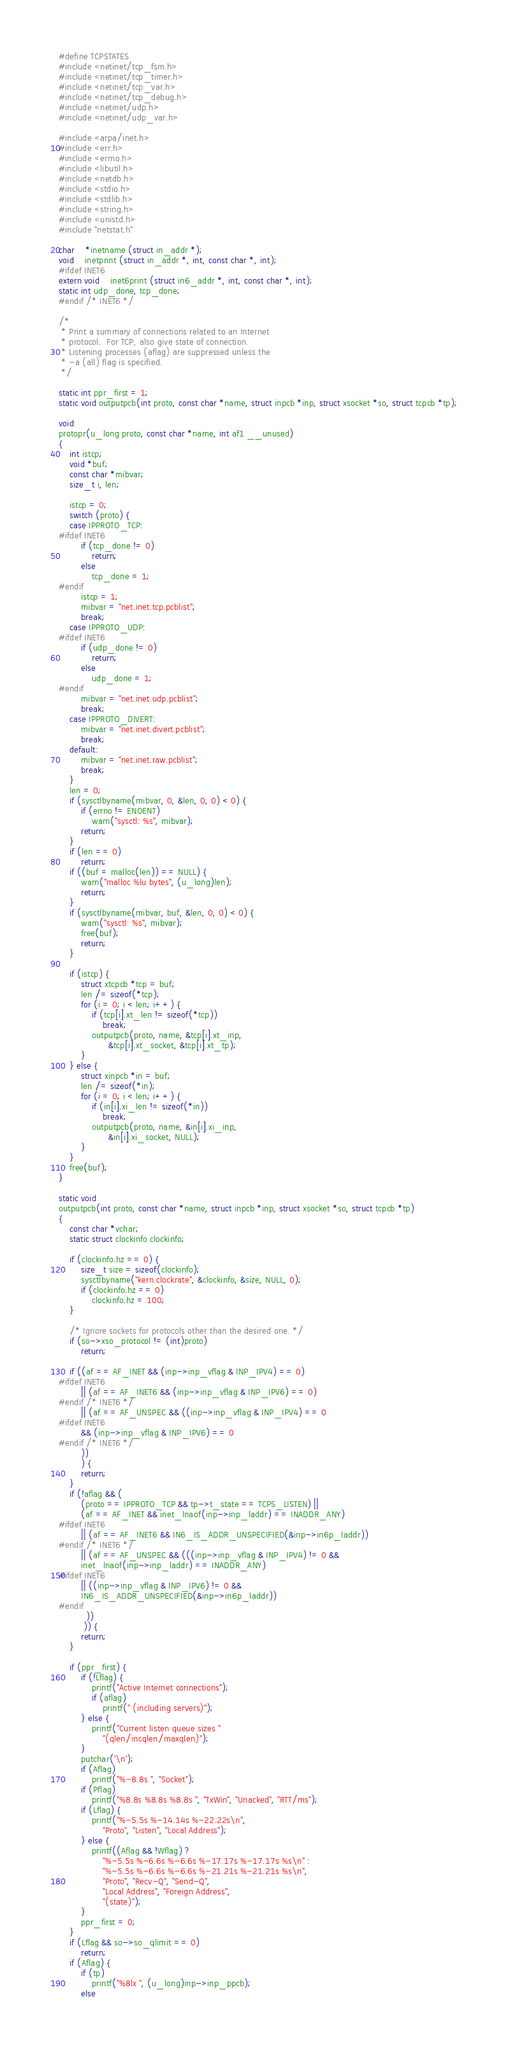Convert code to text. <code><loc_0><loc_0><loc_500><loc_500><_C_>#define TCPSTATES
#include <netinet/tcp_fsm.h>
#include <netinet/tcp_timer.h>
#include <netinet/tcp_var.h>
#include <netinet/tcp_debug.h>
#include <netinet/udp.h>
#include <netinet/udp_var.h>

#include <arpa/inet.h>
#include <err.h>
#include <errno.h>
#include <libutil.h>
#include <netdb.h>
#include <stdio.h>
#include <stdlib.h>
#include <string.h>
#include <unistd.h>
#include "netstat.h"

char	*inetname (struct in_addr *);
void	inetprint (struct in_addr *, int, const char *, int);
#ifdef INET6
extern void	inet6print (struct in6_addr *, int, const char *, int);
static int udp_done, tcp_done;
#endif /* INET6 */

/*
 * Print a summary of connections related to an Internet
 * protocol.  For TCP, also give state of connection.
 * Listening processes (aflag) are suppressed unless the
 * -a (all) flag is specified.
 */

static int ppr_first = 1;
static void outputpcb(int proto, const char *name, struct inpcb *inp, struct xsocket *so, struct tcpcb *tp);

void
protopr(u_long proto, const char *name, int af1 __unused)
{
	int istcp;
	void *buf;
	const char *mibvar;
	size_t i, len;

	istcp = 0;
	switch (proto) {
	case IPPROTO_TCP:
#ifdef INET6
		if (tcp_done != 0)
			return;
		else
			tcp_done = 1;
#endif
		istcp = 1;
		mibvar = "net.inet.tcp.pcblist";
		break;
	case IPPROTO_UDP:
#ifdef INET6
		if (udp_done != 0)
			return;
		else
			udp_done = 1;
#endif
		mibvar = "net.inet.udp.pcblist";
		break;
	case IPPROTO_DIVERT:
		mibvar = "net.inet.divert.pcblist";
		break;
	default:
		mibvar = "net.inet.raw.pcblist";
		break;
	}
	len = 0;
	if (sysctlbyname(mibvar, 0, &len, 0, 0) < 0) {
		if (errno != ENOENT)
			warn("sysctl: %s", mibvar);
		return;
	}
	if (len == 0)
		return;
	if ((buf = malloc(len)) == NULL) {
		warn("malloc %lu bytes", (u_long)len);
		return;
	}
	if (sysctlbyname(mibvar, buf, &len, 0, 0) < 0) {
		warn("sysctl: %s", mibvar);
		free(buf);
		return;
	}

	if (istcp) {
		struct xtcpcb *tcp = buf;
		len /= sizeof(*tcp);
		for (i = 0; i < len; i++) {
			if (tcp[i].xt_len != sizeof(*tcp))
				break;
			outputpcb(proto, name, &tcp[i].xt_inp,
				  &tcp[i].xt_socket, &tcp[i].xt_tp);
		}
	} else {
		struct xinpcb *in = buf;
		len /= sizeof(*in);
		for (i = 0; i < len; i++) {
			if (in[i].xi_len != sizeof(*in))
				break;
			outputpcb(proto, name, &in[i].xi_inp,
				  &in[i].xi_socket, NULL);
		}
	}
	free(buf);
}

static void
outputpcb(int proto, const char *name, struct inpcb *inp, struct xsocket *so, struct tcpcb *tp)
{
	const char *vchar;
	static struct clockinfo clockinfo;

	if (clockinfo.hz == 0) {
		size_t size = sizeof(clockinfo);
		sysctlbyname("kern.clockrate", &clockinfo, &size, NULL, 0);
		if (clockinfo.hz == 0)
			clockinfo.hz = 100;
	}

	/* Ignore sockets for protocols other than the desired one. */
	if (so->xso_protocol != (int)proto)
		return;

	if ((af == AF_INET && (inp->inp_vflag & INP_IPV4) == 0)
#ifdef INET6
	    || (af == AF_INET6 && (inp->inp_vflag & INP_IPV6) == 0)
#endif /* INET6 */
	    || (af == AF_UNSPEC && ((inp->inp_vflag & INP_IPV4) == 0
#ifdef INET6
		&& (inp->inp_vflag & INP_IPV6) == 0
#endif /* INET6 */
		))
	    ) {
		return;
	}
	if (!aflag && ( 
		(proto == IPPROTO_TCP && tp->t_state == TCPS_LISTEN) ||
		(af == AF_INET && inet_lnaof(inp->inp_laddr) == INADDR_ANY)
#ifdef INET6
	    || (af == AF_INET6 && IN6_IS_ADDR_UNSPECIFIED(&inp->in6p_laddr))
#endif /* INET6 */
	    || (af == AF_UNSPEC && (((inp->inp_vflag & INP_IPV4) != 0 &&
		inet_lnaof(inp->inp_laddr) == INADDR_ANY)
#ifdef INET6
	    || ((inp->inp_vflag & INP_IPV6) != 0 &&
		IN6_IS_ADDR_UNSPECIFIED(&inp->in6p_laddr))
#endif
		  ))
	     )) {
		return;
	}

	if (ppr_first) {
		if (!Lflag) {
			printf("Active Internet connections");
			if (aflag)
				printf(" (including servers)");
		} else {
			printf("Current listen queue sizes "
				"(qlen/incqlen/maxqlen)");
		}
		putchar('\n');
		if (Aflag)
			printf("%-8.8s ", "Socket");
		if (Pflag)
			printf("%8.8s %8.8s %8.8s ", "TxWin", "Unacked", "RTT/ms");
		if (Lflag) {
			printf("%-5.5s %-14.14s %-22.22s\n",
				"Proto", "Listen", "Local Address");
		} else {
			printf((Aflag && !Wflag) ?
			    "%-5.5s %-6.6s %-6.6s %-17.17s %-17.17s %s\n" :
			    "%-5.5s %-6.6s %-6.6s %-21.21s %-21.21s %s\n",
			    "Proto", "Recv-Q", "Send-Q",
			    "Local Address", "Foreign Address",
			    "(state)");
		}
		ppr_first = 0;
	}
	if (Lflag && so->so_qlimit == 0)
		return;
	if (Aflag) {
		if (tp)
			printf("%8lx ", (u_long)inp->inp_ppcb);
		else</code> 